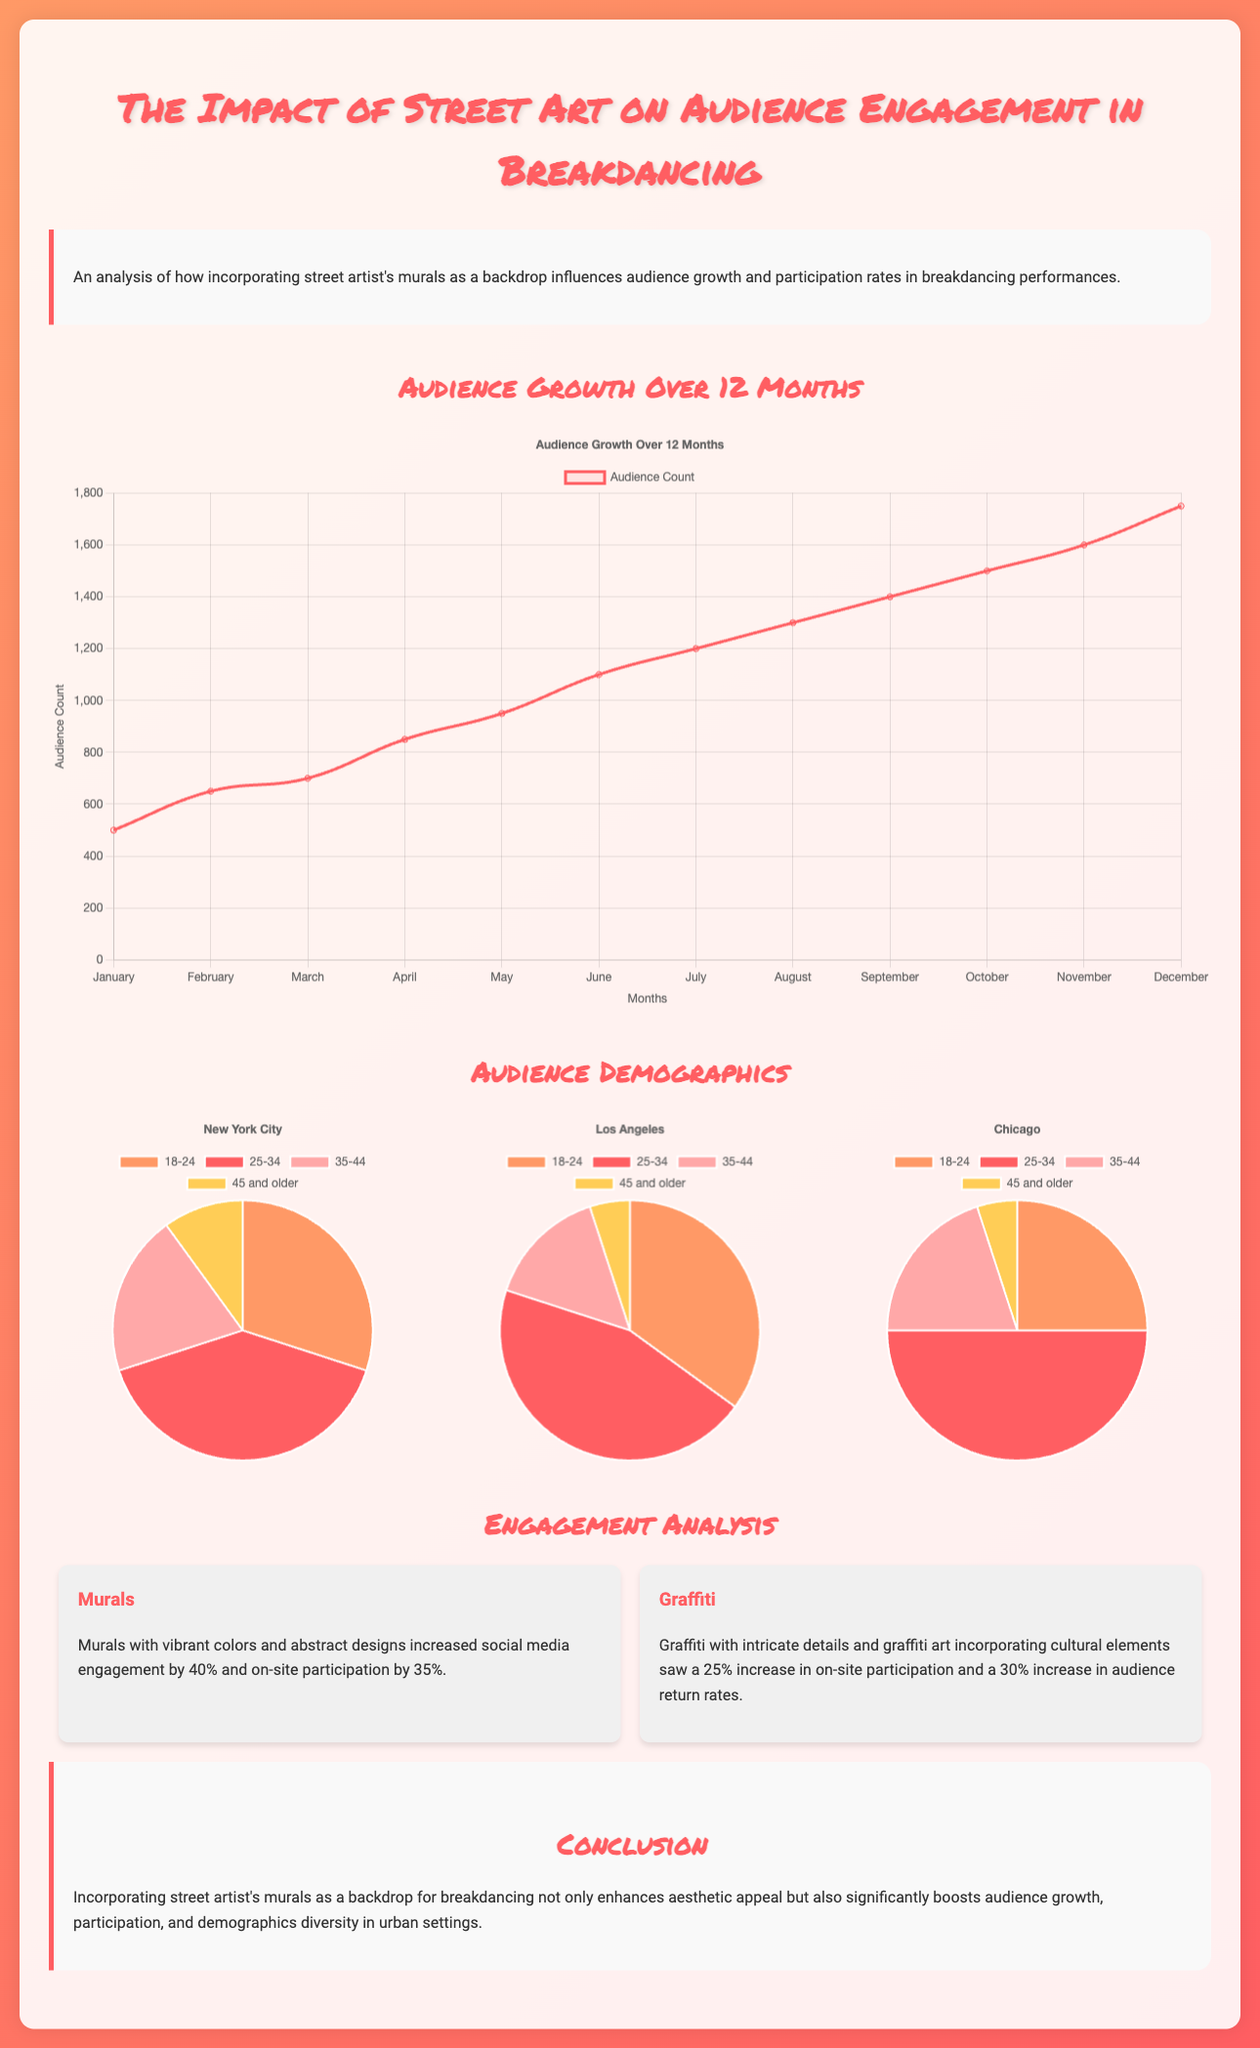what was the audience count in July? The audience count for July is indicated on the audience growth chart as 1200.
Answer: 1200 which month had the highest audience count? The audience growth chart shows that the highest audience count occurred in December, with a total of 1750.
Answer: December what percentage increase in social media engagement did murals provide? The document states that murals increased social media engagement by 40%.
Answer: 40% how many audience members aged 25-34 are in New York City? The demographics chart for New York City indicates that 40% of the audience is aged 25-34.
Answer: 40% which city's audience has the highest percentage of participants aged 18-24? A comparison of the demographics shows that Los Angeles has the highest percentage, with 35% in the 18-24 age group.
Answer: Los Angeles what type of street art had a 25% increase in on-site participation? The document mentions that graffiti with intricate details saw a 25% increase in on-site participation.
Answer: Graffiti what is the total audience growth from January to December? By subtracting the audience count in January (500) from that in December (1750), the total audience growth is calculated.
Answer: 1250 during which month did the audience experience the first decrease in growth rate? Analyzing the audience growth chart, there are no decreases visible; growth continued month by month without a drop.
Answer: N/A 